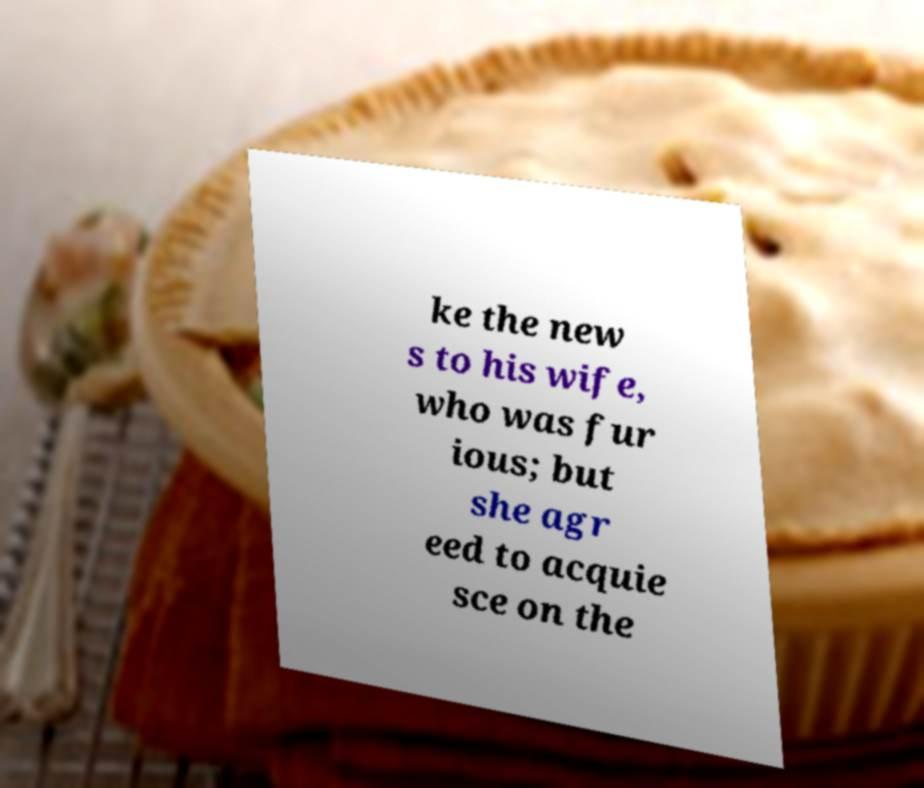Could you extract and type out the text from this image? ke the new s to his wife, who was fur ious; but she agr eed to acquie sce on the 